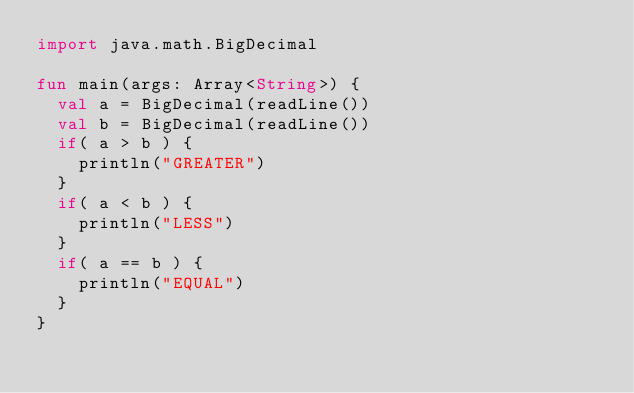<code> <loc_0><loc_0><loc_500><loc_500><_Kotlin_>import java.math.BigDecimal

fun main(args: Array<String>) {
  val a = BigDecimal(readLine())
  val b = BigDecimal(readLine())
  if( a > b ) {
    println("GREATER")
  }
  if( a < b ) {
    println("LESS")
  }
  if( a == b ) {
    println("EQUAL")
  }
}</code> 